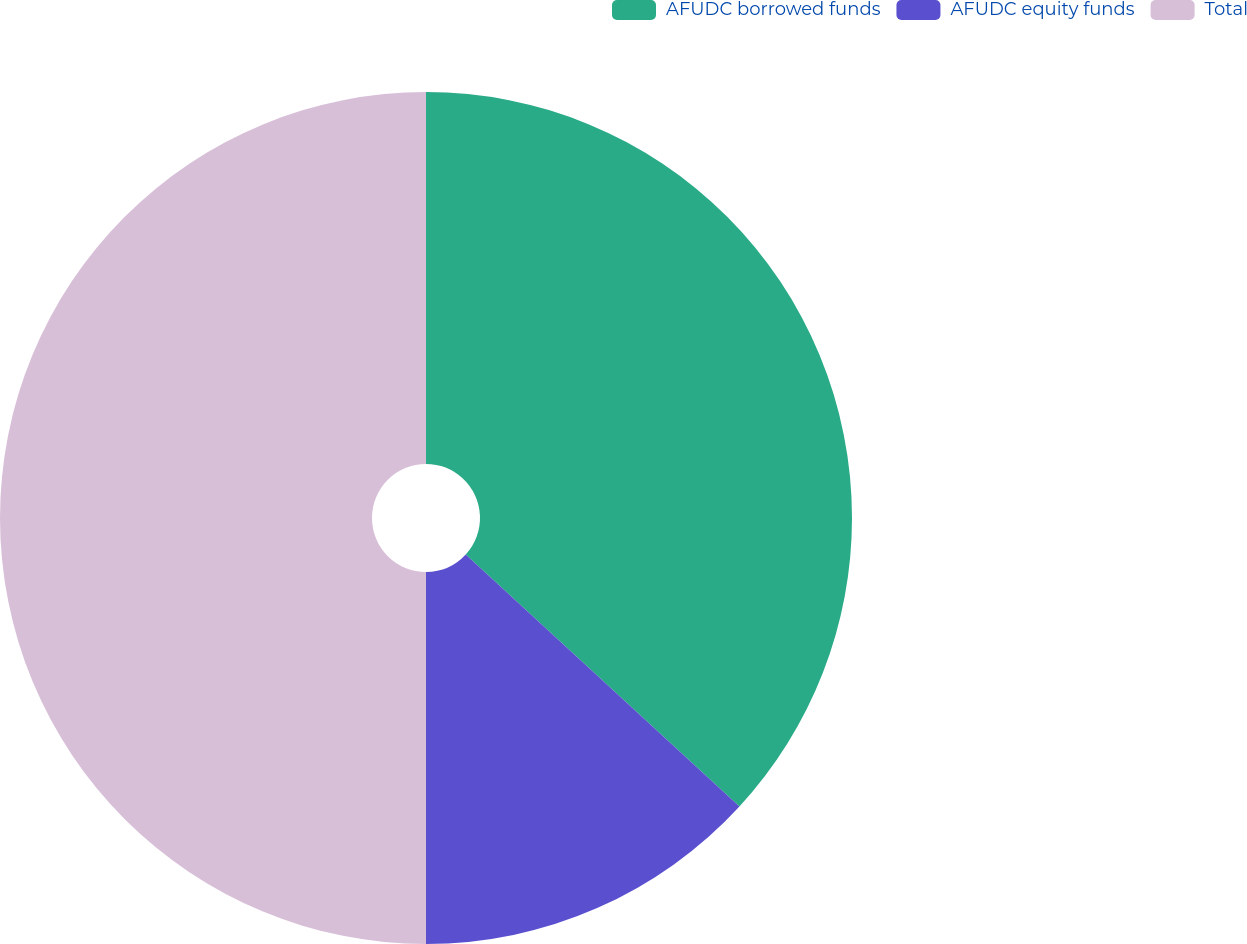<chart> <loc_0><loc_0><loc_500><loc_500><pie_chart><fcel>AFUDC borrowed funds<fcel>AFUDC equity funds<fcel>Total<nl><fcel>36.84%<fcel>13.16%<fcel>50.0%<nl></chart> 